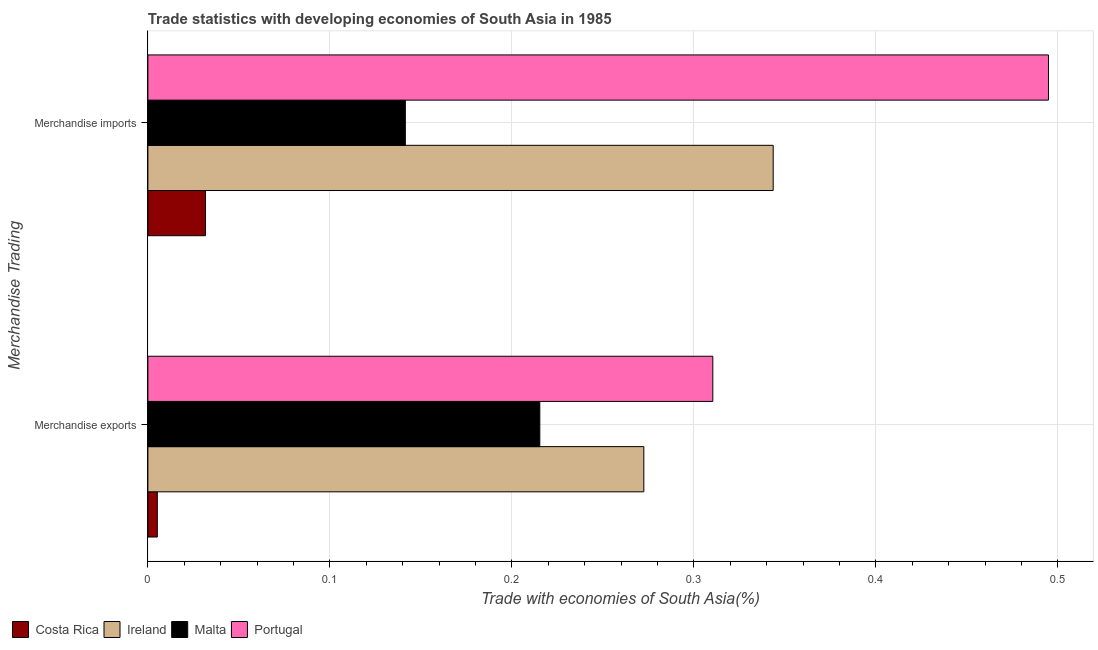Are the number of bars per tick equal to the number of legend labels?
Ensure brevity in your answer.  Yes. What is the merchandise imports in Malta?
Your answer should be compact. 0.14. Across all countries, what is the maximum merchandise imports?
Your response must be concise. 0.49. Across all countries, what is the minimum merchandise imports?
Keep it short and to the point. 0.03. What is the total merchandise imports in the graph?
Make the answer very short. 1.01. What is the difference between the merchandise imports in Portugal and that in Ireland?
Make the answer very short. 0.15. What is the difference between the merchandise imports in Malta and the merchandise exports in Ireland?
Offer a very short reply. -0.13. What is the average merchandise exports per country?
Your response must be concise. 0.2. What is the difference between the merchandise exports and merchandise imports in Malta?
Your response must be concise. 0.07. What is the ratio of the merchandise exports in Ireland to that in Malta?
Provide a succinct answer. 1.27. In how many countries, is the merchandise imports greater than the average merchandise imports taken over all countries?
Offer a terse response. 2. What does the 2nd bar from the top in Merchandise imports represents?
Provide a succinct answer. Malta. What does the 1st bar from the bottom in Merchandise exports represents?
Your response must be concise. Costa Rica. How many bars are there?
Your answer should be very brief. 8. Are all the bars in the graph horizontal?
Ensure brevity in your answer.  Yes. How many countries are there in the graph?
Your answer should be compact. 4. Are the values on the major ticks of X-axis written in scientific E-notation?
Give a very brief answer. No. Does the graph contain grids?
Give a very brief answer. Yes. Where does the legend appear in the graph?
Make the answer very short. Bottom left. How many legend labels are there?
Your answer should be compact. 4. How are the legend labels stacked?
Provide a short and direct response. Horizontal. What is the title of the graph?
Make the answer very short. Trade statistics with developing economies of South Asia in 1985. Does "Montenegro" appear as one of the legend labels in the graph?
Ensure brevity in your answer.  No. What is the label or title of the X-axis?
Your answer should be very brief. Trade with economies of South Asia(%). What is the label or title of the Y-axis?
Give a very brief answer. Merchandise Trading. What is the Trade with economies of South Asia(%) in Costa Rica in Merchandise exports?
Your answer should be very brief. 0.01. What is the Trade with economies of South Asia(%) of Ireland in Merchandise exports?
Make the answer very short. 0.27. What is the Trade with economies of South Asia(%) in Malta in Merchandise exports?
Offer a terse response. 0.22. What is the Trade with economies of South Asia(%) in Portugal in Merchandise exports?
Make the answer very short. 0.31. What is the Trade with economies of South Asia(%) of Costa Rica in Merchandise imports?
Your answer should be very brief. 0.03. What is the Trade with economies of South Asia(%) in Ireland in Merchandise imports?
Make the answer very short. 0.34. What is the Trade with economies of South Asia(%) in Malta in Merchandise imports?
Provide a succinct answer. 0.14. What is the Trade with economies of South Asia(%) of Portugal in Merchandise imports?
Offer a very short reply. 0.49. Across all Merchandise Trading, what is the maximum Trade with economies of South Asia(%) in Costa Rica?
Offer a terse response. 0.03. Across all Merchandise Trading, what is the maximum Trade with economies of South Asia(%) in Ireland?
Your answer should be very brief. 0.34. Across all Merchandise Trading, what is the maximum Trade with economies of South Asia(%) of Malta?
Provide a short and direct response. 0.22. Across all Merchandise Trading, what is the maximum Trade with economies of South Asia(%) in Portugal?
Provide a succinct answer. 0.49. Across all Merchandise Trading, what is the minimum Trade with economies of South Asia(%) in Costa Rica?
Your answer should be compact. 0.01. Across all Merchandise Trading, what is the minimum Trade with economies of South Asia(%) in Ireland?
Your answer should be very brief. 0.27. Across all Merchandise Trading, what is the minimum Trade with economies of South Asia(%) in Malta?
Offer a terse response. 0.14. Across all Merchandise Trading, what is the minimum Trade with economies of South Asia(%) of Portugal?
Offer a terse response. 0.31. What is the total Trade with economies of South Asia(%) of Costa Rica in the graph?
Keep it short and to the point. 0.04. What is the total Trade with economies of South Asia(%) in Ireland in the graph?
Your answer should be compact. 0.62. What is the total Trade with economies of South Asia(%) in Malta in the graph?
Offer a very short reply. 0.36. What is the total Trade with economies of South Asia(%) of Portugal in the graph?
Your answer should be very brief. 0.81. What is the difference between the Trade with economies of South Asia(%) in Costa Rica in Merchandise exports and that in Merchandise imports?
Provide a succinct answer. -0.03. What is the difference between the Trade with economies of South Asia(%) in Ireland in Merchandise exports and that in Merchandise imports?
Give a very brief answer. -0.07. What is the difference between the Trade with economies of South Asia(%) in Malta in Merchandise exports and that in Merchandise imports?
Make the answer very short. 0.07. What is the difference between the Trade with economies of South Asia(%) in Portugal in Merchandise exports and that in Merchandise imports?
Your answer should be very brief. -0.18. What is the difference between the Trade with economies of South Asia(%) in Costa Rica in Merchandise exports and the Trade with economies of South Asia(%) in Ireland in Merchandise imports?
Give a very brief answer. -0.34. What is the difference between the Trade with economies of South Asia(%) in Costa Rica in Merchandise exports and the Trade with economies of South Asia(%) in Malta in Merchandise imports?
Your answer should be compact. -0.14. What is the difference between the Trade with economies of South Asia(%) in Costa Rica in Merchandise exports and the Trade with economies of South Asia(%) in Portugal in Merchandise imports?
Ensure brevity in your answer.  -0.49. What is the difference between the Trade with economies of South Asia(%) in Ireland in Merchandise exports and the Trade with economies of South Asia(%) in Malta in Merchandise imports?
Provide a short and direct response. 0.13. What is the difference between the Trade with economies of South Asia(%) in Ireland in Merchandise exports and the Trade with economies of South Asia(%) in Portugal in Merchandise imports?
Make the answer very short. -0.22. What is the difference between the Trade with economies of South Asia(%) of Malta in Merchandise exports and the Trade with economies of South Asia(%) of Portugal in Merchandise imports?
Ensure brevity in your answer.  -0.28. What is the average Trade with economies of South Asia(%) in Costa Rica per Merchandise Trading?
Keep it short and to the point. 0.02. What is the average Trade with economies of South Asia(%) of Ireland per Merchandise Trading?
Your answer should be compact. 0.31. What is the average Trade with economies of South Asia(%) of Malta per Merchandise Trading?
Offer a terse response. 0.18. What is the average Trade with economies of South Asia(%) of Portugal per Merchandise Trading?
Ensure brevity in your answer.  0.4. What is the difference between the Trade with economies of South Asia(%) in Costa Rica and Trade with economies of South Asia(%) in Ireland in Merchandise exports?
Your answer should be compact. -0.27. What is the difference between the Trade with economies of South Asia(%) of Costa Rica and Trade with economies of South Asia(%) of Malta in Merchandise exports?
Give a very brief answer. -0.21. What is the difference between the Trade with economies of South Asia(%) of Costa Rica and Trade with economies of South Asia(%) of Portugal in Merchandise exports?
Offer a very short reply. -0.31. What is the difference between the Trade with economies of South Asia(%) of Ireland and Trade with economies of South Asia(%) of Malta in Merchandise exports?
Ensure brevity in your answer.  0.06. What is the difference between the Trade with economies of South Asia(%) in Ireland and Trade with economies of South Asia(%) in Portugal in Merchandise exports?
Provide a succinct answer. -0.04. What is the difference between the Trade with economies of South Asia(%) in Malta and Trade with economies of South Asia(%) in Portugal in Merchandise exports?
Offer a terse response. -0.1. What is the difference between the Trade with economies of South Asia(%) of Costa Rica and Trade with economies of South Asia(%) of Ireland in Merchandise imports?
Your response must be concise. -0.31. What is the difference between the Trade with economies of South Asia(%) of Costa Rica and Trade with economies of South Asia(%) of Malta in Merchandise imports?
Provide a succinct answer. -0.11. What is the difference between the Trade with economies of South Asia(%) in Costa Rica and Trade with economies of South Asia(%) in Portugal in Merchandise imports?
Ensure brevity in your answer.  -0.46. What is the difference between the Trade with economies of South Asia(%) of Ireland and Trade with economies of South Asia(%) of Malta in Merchandise imports?
Your answer should be compact. 0.2. What is the difference between the Trade with economies of South Asia(%) in Ireland and Trade with economies of South Asia(%) in Portugal in Merchandise imports?
Provide a succinct answer. -0.15. What is the difference between the Trade with economies of South Asia(%) in Malta and Trade with economies of South Asia(%) in Portugal in Merchandise imports?
Your answer should be very brief. -0.35. What is the ratio of the Trade with economies of South Asia(%) of Costa Rica in Merchandise exports to that in Merchandise imports?
Ensure brevity in your answer.  0.16. What is the ratio of the Trade with economies of South Asia(%) in Ireland in Merchandise exports to that in Merchandise imports?
Your answer should be very brief. 0.79. What is the ratio of the Trade with economies of South Asia(%) of Malta in Merchandise exports to that in Merchandise imports?
Your response must be concise. 1.52. What is the ratio of the Trade with economies of South Asia(%) in Portugal in Merchandise exports to that in Merchandise imports?
Make the answer very short. 0.63. What is the difference between the highest and the second highest Trade with economies of South Asia(%) in Costa Rica?
Give a very brief answer. 0.03. What is the difference between the highest and the second highest Trade with economies of South Asia(%) of Ireland?
Your response must be concise. 0.07. What is the difference between the highest and the second highest Trade with economies of South Asia(%) of Malta?
Keep it short and to the point. 0.07. What is the difference between the highest and the second highest Trade with economies of South Asia(%) of Portugal?
Make the answer very short. 0.18. What is the difference between the highest and the lowest Trade with economies of South Asia(%) in Costa Rica?
Provide a short and direct response. 0.03. What is the difference between the highest and the lowest Trade with economies of South Asia(%) in Ireland?
Provide a short and direct response. 0.07. What is the difference between the highest and the lowest Trade with economies of South Asia(%) in Malta?
Keep it short and to the point. 0.07. What is the difference between the highest and the lowest Trade with economies of South Asia(%) in Portugal?
Ensure brevity in your answer.  0.18. 